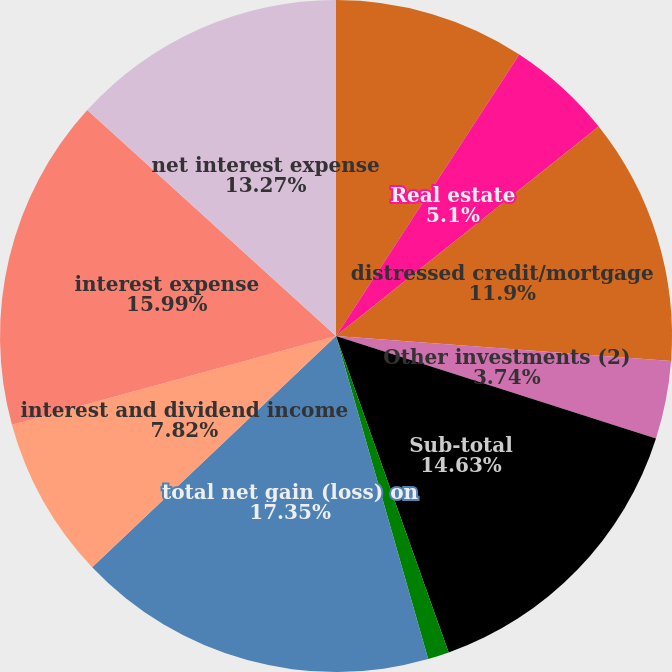Convert chart to OTSL. <chart><loc_0><loc_0><loc_500><loc_500><pie_chart><fcel>private equity<fcel>Real estate<fcel>distressed credit/mortgage<fcel>Other investments (2)<fcel>Sub-total<fcel>investments related to<fcel>total net gain (loss) on<fcel>interest and dividend income<fcel>interest expense<fcel>net interest expense<nl><fcel>9.18%<fcel>5.1%<fcel>11.9%<fcel>3.74%<fcel>14.62%<fcel>1.02%<fcel>17.34%<fcel>7.82%<fcel>15.98%<fcel>13.26%<nl></chart> 